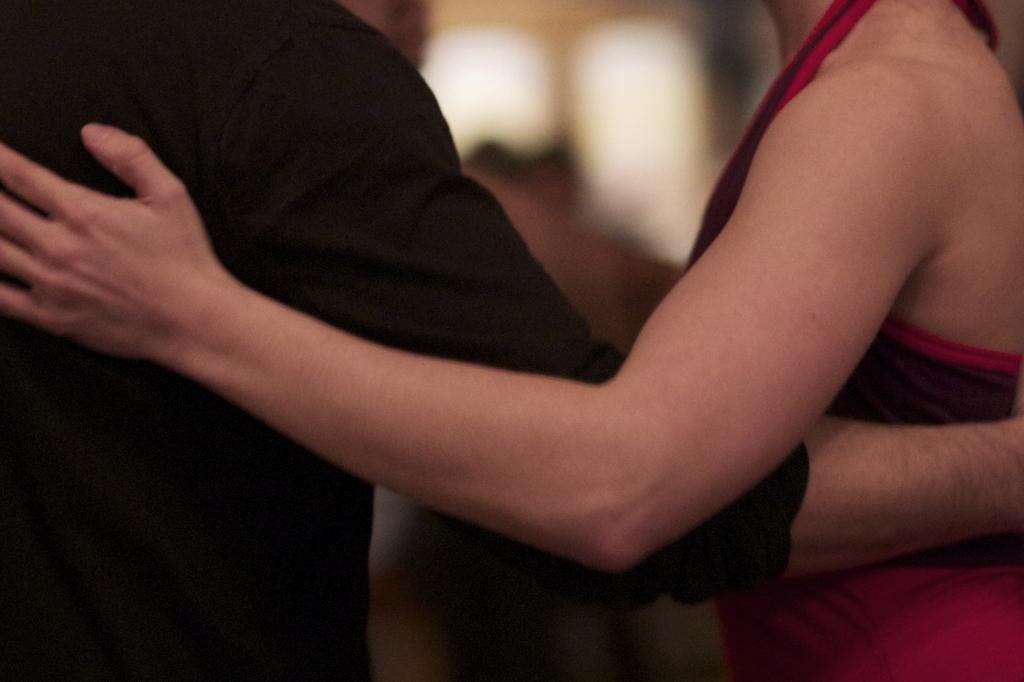Describe this image in one or two sentences. In this image, we can see persons wearing clothes. 